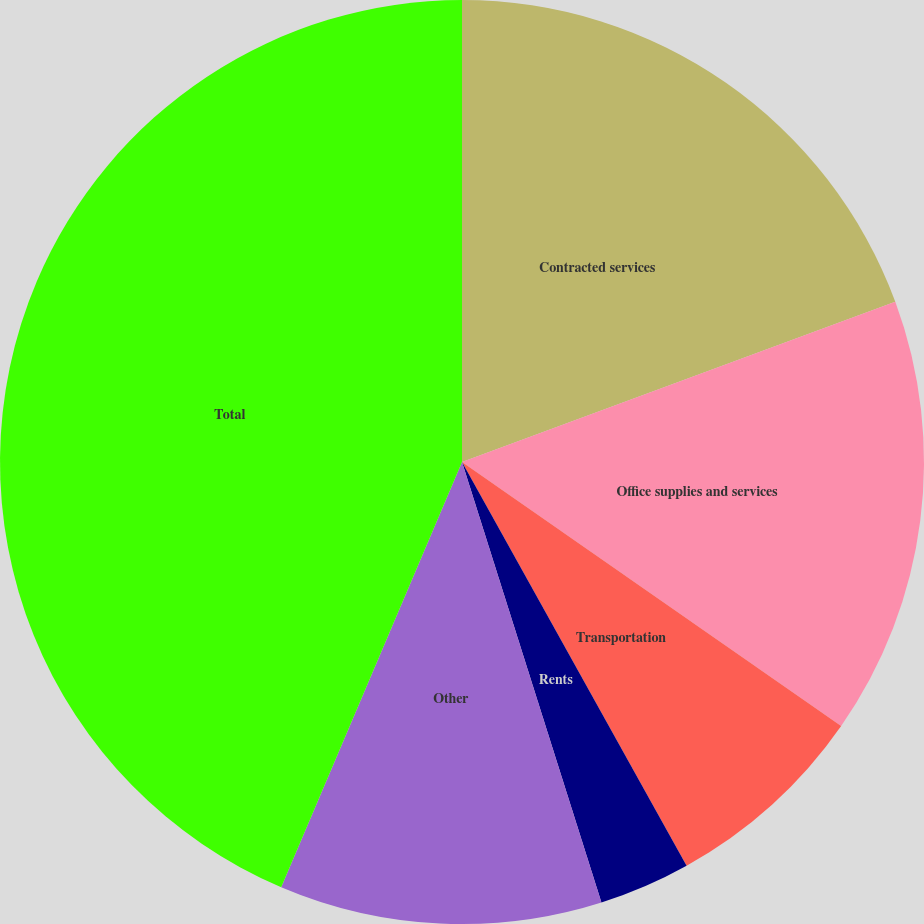Convert chart. <chart><loc_0><loc_0><loc_500><loc_500><pie_chart><fcel>Contracted services<fcel>Office supplies and services<fcel>Transportation<fcel>Rents<fcel>Other<fcel>Total<nl><fcel>19.36%<fcel>15.32%<fcel>7.24%<fcel>3.2%<fcel>11.28%<fcel>43.6%<nl></chart> 